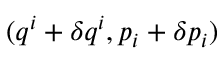Convert formula to latex. <formula><loc_0><loc_0><loc_500><loc_500>( q ^ { i } + \delta q ^ { i } , p _ { i } + \delta p _ { i } )</formula> 